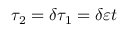Convert formula to latex. <formula><loc_0><loc_0><loc_500><loc_500>\tau _ { 2 } = \delta \tau _ { 1 } = \delta \varepsilon t</formula> 